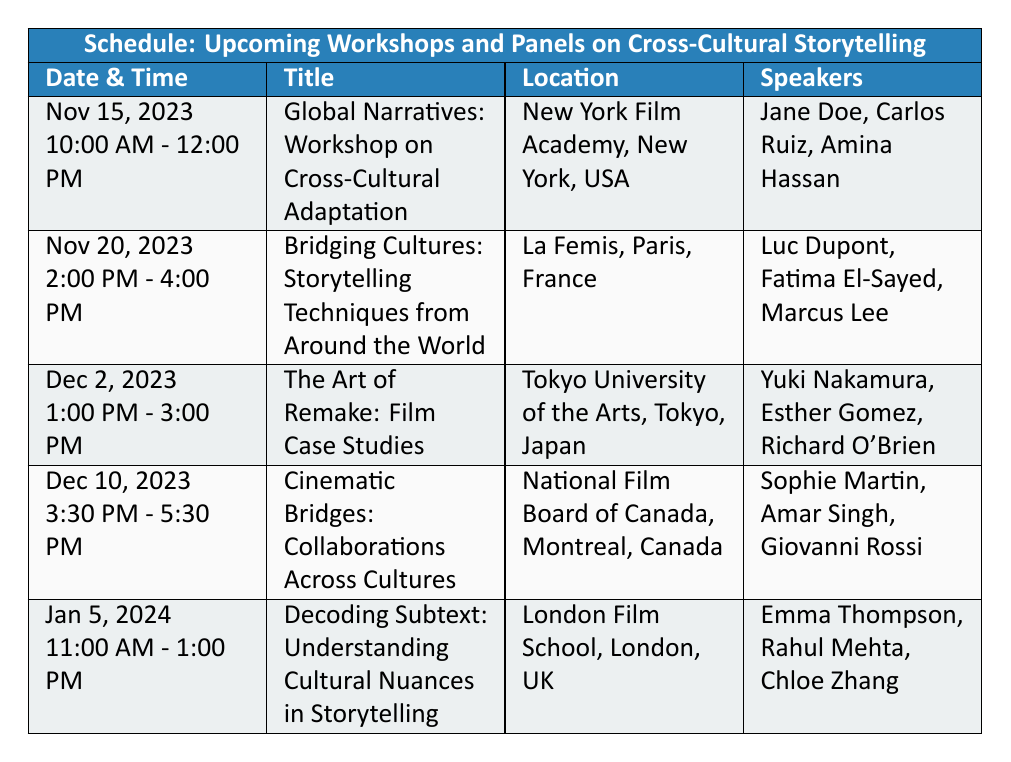What is the date and time of the "Global Narratives" workshop? The table lists the date and time for the "Global Narratives: Workshop on Cross-Cultural Adaptation" as November 15, 2023, from 10:00 AM to 12:00 PM.
Answer: November 15, 2023, 10:00 AM - 12:00 PM Which location hosts the "Cinematic Bridges" workshop? The "Cinematic Bridges: Collaborations Across Cultures" workshop is scheduled to take place at the National Film Board of Canada, Montreal, Canada, as indicated in the table.
Answer: National Film Board of Canada, Montreal, Canada Are there any workshops scheduled in December? Yes, there are two workshops scheduled in December: "The Art of Remake: Film Case Studies" on December 2, 2023, and "Cinematic Bridges: Collaborations Across Cultures" on December 10, 2023.
Answer: Yes Who are the speakers for the workshop on January 5, 2024? The speakers for the "Decoding Subtext: Understanding Cultural Nuances in Storytelling" workshop on January 5, 2024, are Emma Thompson, Rahul Mehta, and Chloe Zhang, as shown in the table.
Answer: Emma Thompson, Rahul Mehta, Chloe Zhang What is the time difference between the "Bridging Cultures" panel and the "Decoding Subtext" workshop? The "Bridging Cultures" panel is from 2:00 PM to 4:00 PM and the "Decoding Subtext" workshop is from 11:00 AM to 1:00 PM. Thus, the time difference is from 4:00 PM to 11:00 AM on January 5, which is 2 hours and 30 minutes (4 PM is 3 hours and 30 minutes after 11 AM).
Answer: 2 hours and 30 minutes Which event has the most speakers listed? Each event has three speakers listed, so to determine if one has more, we can observe that all events have the same count. None has more than three speakers.
Answer: None How many events are scheduled to take place in New York? The table indicates that there is only one event, "Global Narratives: Workshop on Cross-Cultural Adaptation," scheduled for November 15, 2023, in New York. Thus, the count is one.
Answer: One Is there a workshop focused on co-productions? Yes, the "Cinematic Bridges: Collaborations Across Cultures" workshop on December 10, 2023, focuses on collaborative storytelling and co-productions, as indicated in the description.
Answer: Yes What are the dates of all events happening in 2023? The events in 2023 include the following dates: November 15, November 20, December 2, and December 10. Each event corresponds to a specific date listed in the schedule.
Answer: November 15, November 20, December 2, December 10 How many different countries are represented in the locations of these events? The events are spread across five locations: USA (New York), France (Paris), Japan (Tokyo), Canada (Montreal), and UK (London). Counting these gives a total of five different countries represented.
Answer: Five 